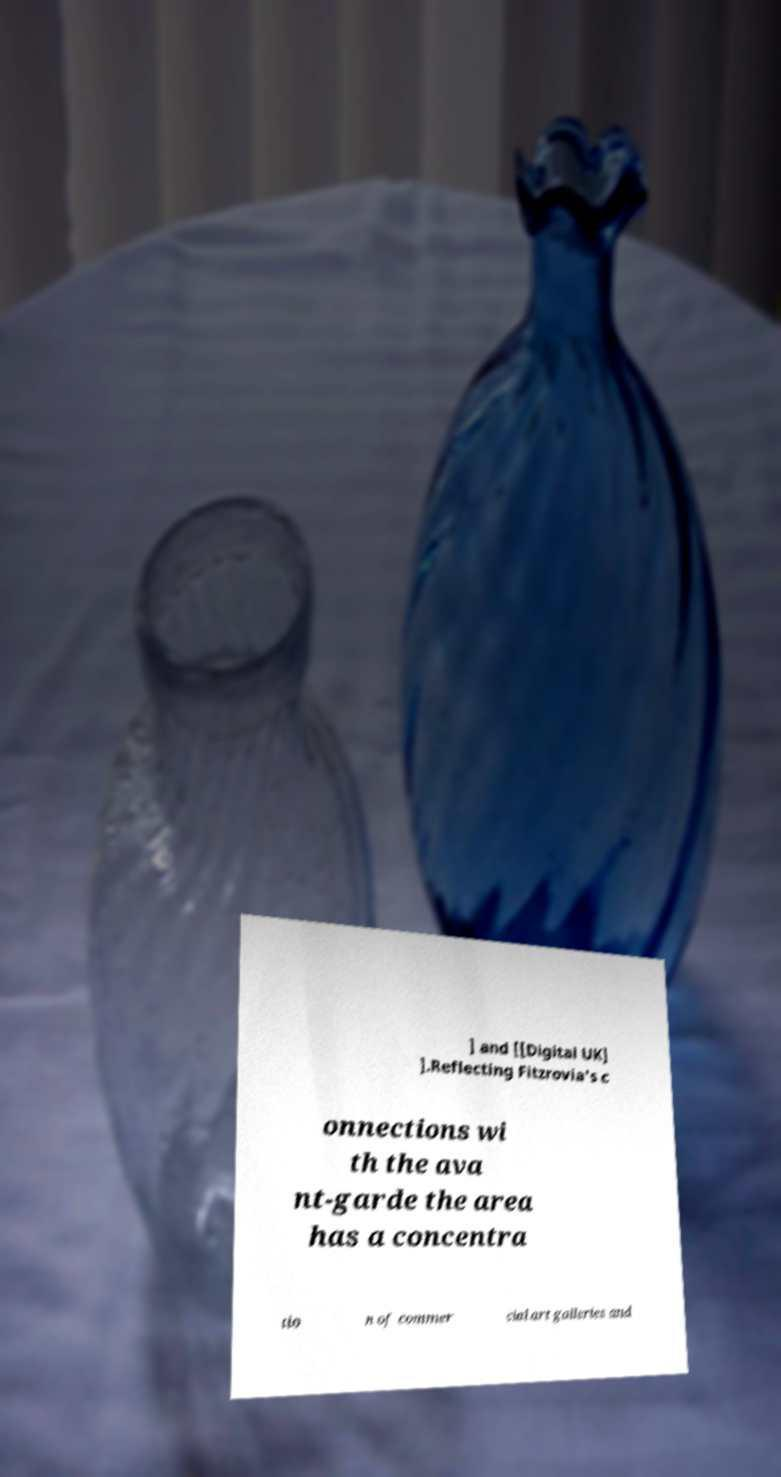Could you extract and type out the text from this image? ] and [[Digital UK] ].Reflecting Fitzrovia's c onnections wi th the ava nt-garde the area has a concentra tio n of commer cial art galleries and 